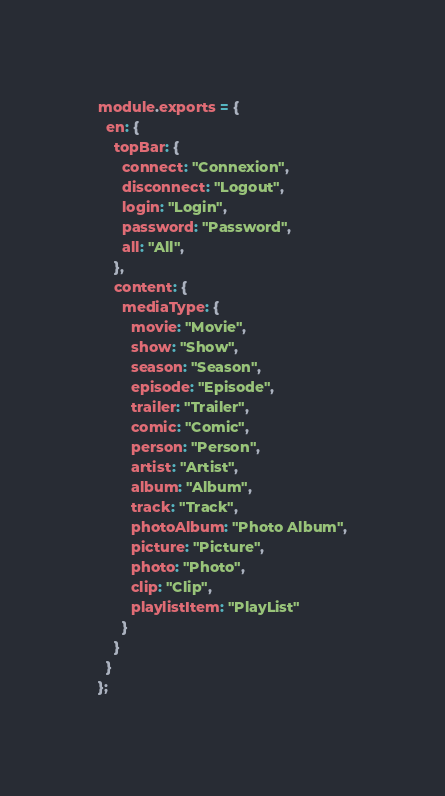<code> <loc_0><loc_0><loc_500><loc_500><_JavaScript_>module.exports = {
  en: {
    topBar: {
      connect: "Connexion",
      disconnect: "Logout",
      login: "Login",
      password: "Password",
      all: "All",
    },
    content: {
      mediaType: {
        movie: "Movie",
        show: "Show",
        season: "Season",
        episode: "Episode",
        trailer: "Trailer",
        comic: "Comic",
        person: "Person",
        artist: "Artist",
        album: "Album",
        track: "Track",
        photoAlbum: "Photo Album",
        picture: "Picture",
        photo: "Photo",
        clip: "Clip",
        playlistItem: "PlayList"
      }
    }
  }
};
</code> 